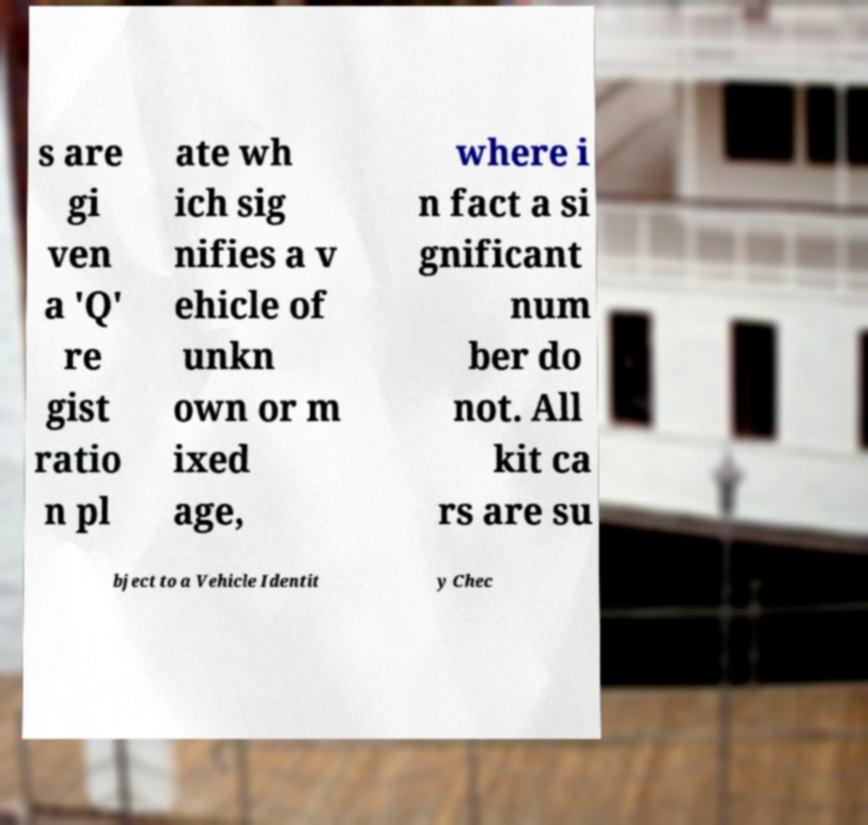What messages or text are displayed in this image? I need them in a readable, typed format. s are gi ven a 'Q' re gist ratio n pl ate wh ich sig nifies a v ehicle of unkn own or m ixed age, where i n fact a si gnificant num ber do not. All kit ca rs are su bject to a Vehicle Identit y Chec 